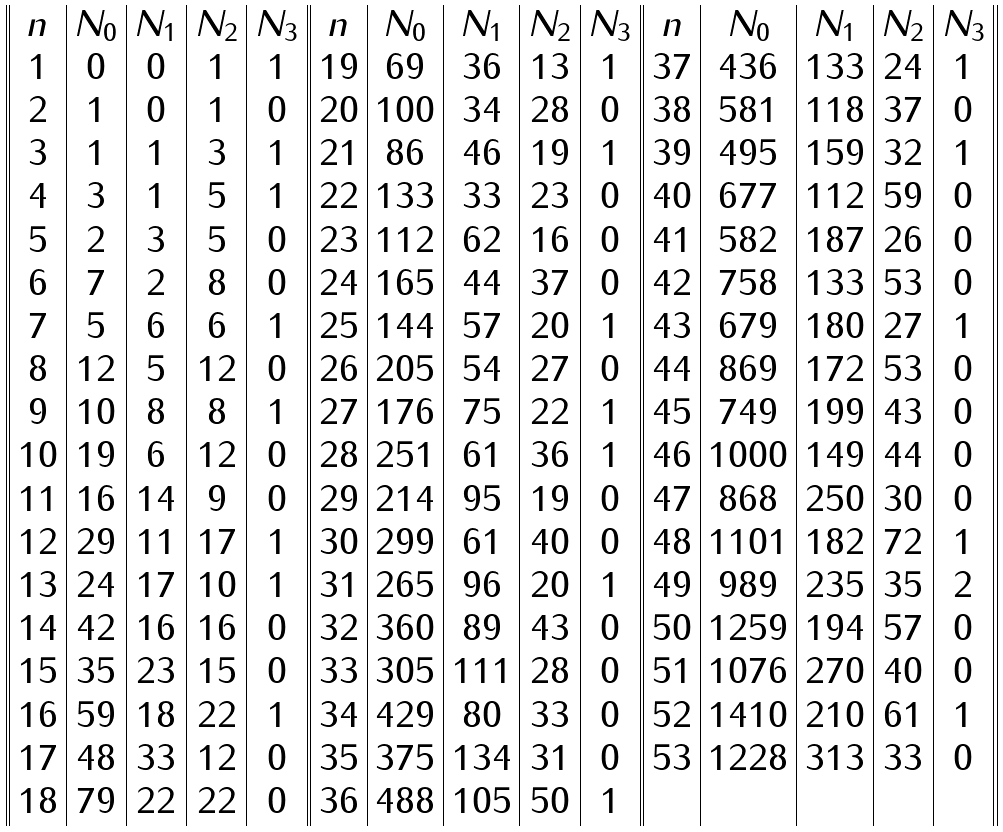<formula> <loc_0><loc_0><loc_500><loc_500>\begin{array} { | | c | c | c | c | c | | c | c | c | c | c | | c | c | c | c | c | | } n & N _ { 0 } & N _ { 1 } & N _ { 2 } & N _ { 3 } & n & N _ { 0 } & N _ { 1 } & N _ { 2 } & N _ { 3 } & n & N _ { 0 } & N _ { 1 } & N _ { 2 } & N _ { 3 } \\ 1 & 0 & 0 & 1 & 1 & 1 9 & 6 9 & 3 6 & 1 3 & 1 & 3 7 & 4 3 6 & 1 3 3 & 2 4 & 1 \\ 2 & 1 & 0 & 1 & 0 & 2 0 & 1 0 0 & 3 4 & 2 8 & 0 & 3 8 & 5 8 1 & 1 1 8 & 3 7 & 0 \\ 3 & 1 & 1 & 3 & 1 & 2 1 & 8 6 & 4 6 & 1 9 & 1 & 3 9 & 4 9 5 & 1 5 9 & 3 2 & 1 \\ 4 & 3 & 1 & 5 & 1 & 2 2 & 1 3 3 & 3 3 & 2 3 & 0 & 4 0 & 6 7 7 & 1 1 2 & 5 9 & 0 \\ 5 & 2 & 3 & 5 & 0 & 2 3 & 1 1 2 & 6 2 & 1 6 & 0 & 4 1 & 5 8 2 & 1 8 7 & 2 6 & 0 \\ 6 & 7 & 2 & 8 & 0 & 2 4 & 1 6 5 & 4 4 & 3 7 & 0 & 4 2 & 7 5 8 & 1 3 3 & 5 3 & 0 \\ 7 & 5 & 6 & 6 & 1 & 2 5 & 1 4 4 & 5 7 & 2 0 & 1 & 4 3 & 6 7 9 & 1 8 0 & 2 7 & 1 \\ 8 & 1 2 & 5 & 1 2 & 0 & 2 6 & 2 0 5 & 5 4 & 2 7 & 0 & 4 4 & 8 6 9 & 1 7 2 & 5 3 & 0 \\ 9 & 1 0 & 8 & 8 & 1 & 2 7 & 1 7 6 & 7 5 & 2 2 & 1 & 4 5 & 7 4 9 & 1 9 9 & 4 3 & 0 \\ 1 0 & 1 9 & 6 & 1 2 & 0 & 2 8 & 2 5 1 & 6 1 & 3 6 & 1 & 4 6 & 1 0 0 0 & 1 4 9 & 4 4 & 0 \\ 1 1 & 1 6 & 1 4 & 9 & 0 & 2 9 & 2 1 4 & 9 5 & 1 9 & 0 & 4 7 & 8 6 8 & 2 5 0 & 3 0 & 0 \\ 1 2 & 2 9 & 1 1 & 1 7 & 1 & 3 0 & 2 9 9 & 6 1 & 4 0 & 0 & 4 8 & 1 1 0 1 & 1 8 2 & 7 2 & 1 \\ 1 3 & 2 4 & 1 7 & 1 0 & 1 & 3 1 & 2 6 5 & 9 6 & 2 0 & 1 & 4 9 & 9 8 9 & 2 3 5 & 3 5 & 2 \\ 1 4 & 4 2 & 1 6 & 1 6 & 0 & 3 2 & 3 6 0 & 8 9 & 4 3 & 0 & 5 0 & 1 2 5 9 & 1 9 4 & 5 7 & 0 \\ 1 5 & 3 5 & 2 3 & 1 5 & 0 & 3 3 & 3 0 5 & 1 1 1 & 2 8 & 0 & 5 1 & 1 0 7 6 & 2 7 0 & 4 0 & 0 \\ 1 6 & 5 9 & 1 8 & 2 2 & 1 & 3 4 & 4 2 9 & 8 0 & 3 3 & 0 & 5 2 & 1 4 1 0 & 2 1 0 & 6 1 & 1 \\ 1 7 & 4 8 & 3 3 & 1 2 & 0 & 3 5 & 3 7 5 & 1 3 4 & 3 1 & 0 & 5 3 & 1 2 2 8 & 3 1 3 & 3 3 & 0 \\ 1 8 & 7 9 & 2 2 & 2 2 & 0 & 3 6 & 4 8 8 & 1 0 5 & 5 0 & 1 & & & & & \\ \end{array}</formula> 